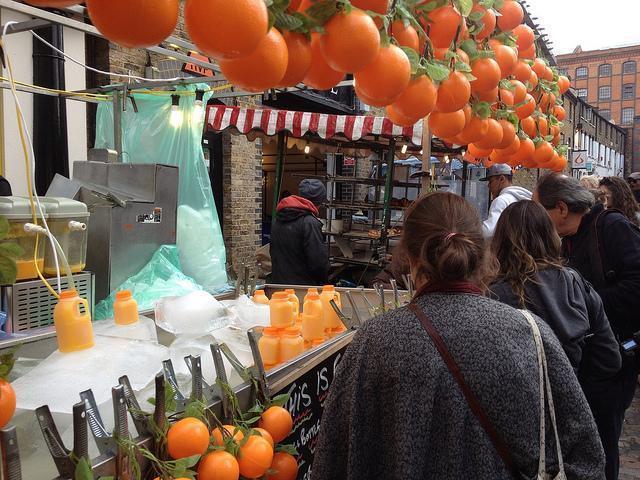The orange orbs seen here are actually what?
Indicate the correct response by choosing from the four available options to answer the question.
Options: Real oranges, plastic, lemons, pinatas. Plastic. 